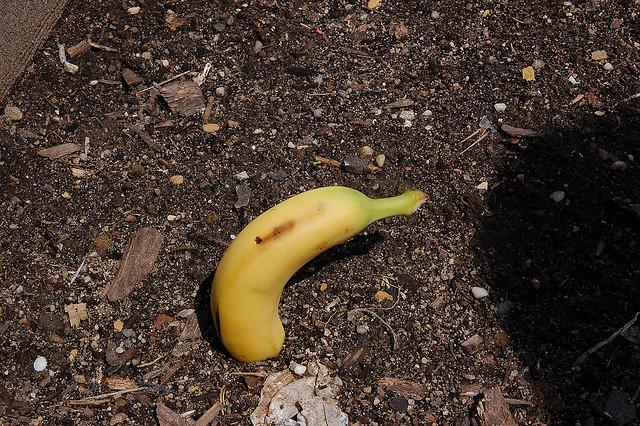What color is the banana?
Write a very short answer. Yellow. Will this grow into a banana tree?
Concise answer only. No. What is planted in the ground?
Short answer required. Banana. 